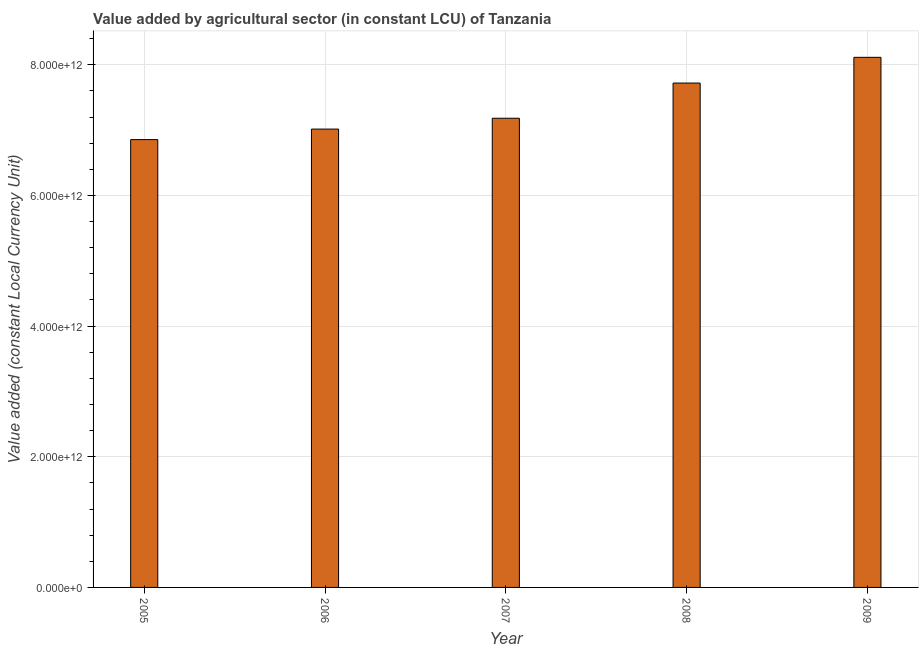Does the graph contain grids?
Make the answer very short. Yes. What is the title of the graph?
Offer a very short reply. Value added by agricultural sector (in constant LCU) of Tanzania. What is the label or title of the X-axis?
Provide a succinct answer. Year. What is the label or title of the Y-axis?
Keep it short and to the point. Value added (constant Local Currency Unit). What is the value added by agriculture sector in 2005?
Your response must be concise. 6.85e+12. Across all years, what is the maximum value added by agriculture sector?
Provide a short and direct response. 8.11e+12. Across all years, what is the minimum value added by agriculture sector?
Your answer should be very brief. 6.85e+12. In which year was the value added by agriculture sector maximum?
Provide a short and direct response. 2009. What is the sum of the value added by agriculture sector?
Keep it short and to the point. 3.69e+13. What is the difference between the value added by agriculture sector in 2005 and 2006?
Keep it short and to the point. -1.61e+11. What is the average value added by agriculture sector per year?
Provide a short and direct response. 7.38e+12. What is the median value added by agriculture sector?
Give a very brief answer. 7.18e+12. Do a majority of the years between 2006 and 2005 (inclusive) have value added by agriculture sector greater than 4800000000000 LCU?
Your answer should be very brief. No. What is the ratio of the value added by agriculture sector in 2005 to that in 2007?
Make the answer very short. 0.95. Is the difference between the value added by agriculture sector in 2006 and 2008 greater than the difference between any two years?
Provide a succinct answer. No. What is the difference between the highest and the second highest value added by agriculture sector?
Provide a succinct answer. 3.94e+11. What is the difference between the highest and the lowest value added by agriculture sector?
Your answer should be very brief. 1.26e+12. Are all the bars in the graph horizontal?
Offer a terse response. No. How many years are there in the graph?
Ensure brevity in your answer.  5. What is the difference between two consecutive major ticks on the Y-axis?
Make the answer very short. 2.00e+12. Are the values on the major ticks of Y-axis written in scientific E-notation?
Offer a terse response. Yes. What is the Value added (constant Local Currency Unit) of 2005?
Ensure brevity in your answer.  6.85e+12. What is the Value added (constant Local Currency Unit) of 2006?
Provide a short and direct response. 7.02e+12. What is the Value added (constant Local Currency Unit) in 2007?
Your answer should be compact. 7.18e+12. What is the Value added (constant Local Currency Unit) of 2008?
Keep it short and to the point. 7.72e+12. What is the Value added (constant Local Currency Unit) of 2009?
Provide a short and direct response. 8.11e+12. What is the difference between the Value added (constant Local Currency Unit) in 2005 and 2006?
Your answer should be compact. -1.61e+11. What is the difference between the Value added (constant Local Currency Unit) in 2005 and 2007?
Provide a succinct answer. -3.27e+11. What is the difference between the Value added (constant Local Currency Unit) in 2005 and 2008?
Your response must be concise. -8.66e+11. What is the difference between the Value added (constant Local Currency Unit) in 2005 and 2009?
Make the answer very short. -1.26e+12. What is the difference between the Value added (constant Local Currency Unit) in 2006 and 2007?
Provide a succinct answer. -1.66e+11. What is the difference between the Value added (constant Local Currency Unit) in 2006 and 2008?
Provide a succinct answer. -7.04e+11. What is the difference between the Value added (constant Local Currency Unit) in 2006 and 2009?
Ensure brevity in your answer.  -1.10e+12. What is the difference between the Value added (constant Local Currency Unit) in 2007 and 2008?
Your answer should be very brief. -5.39e+11. What is the difference between the Value added (constant Local Currency Unit) in 2007 and 2009?
Provide a succinct answer. -9.32e+11. What is the difference between the Value added (constant Local Currency Unit) in 2008 and 2009?
Ensure brevity in your answer.  -3.94e+11. What is the ratio of the Value added (constant Local Currency Unit) in 2005 to that in 2007?
Keep it short and to the point. 0.95. What is the ratio of the Value added (constant Local Currency Unit) in 2005 to that in 2008?
Keep it short and to the point. 0.89. What is the ratio of the Value added (constant Local Currency Unit) in 2005 to that in 2009?
Offer a terse response. 0.84. What is the ratio of the Value added (constant Local Currency Unit) in 2006 to that in 2007?
Offer a very short reply. 0.98. What is the ratio of the Value added (constant Local Currency Unit) in 2006 to that in 2008?
Ensure brevity in your answer.  0.91. What is the ratio of the Value added (constant Local Currency Unit) in 2006 to that in 2009?
Give a very brief answer. 0.86. What is the ratio of the Value added (constant Local Currency Unit) in 2007 to that in 2008?
Your answer should be compact. 0.93. What is the ratio of the Value added (constant Local Currency Unit) in 2007 to that in 2009?
Your answer should be very brief. 0.89. What is the ratio of the Value added (constant Local Currency Unit) in 2008 to that in 2009?
Ensure brevity in your answer.  0.95. 